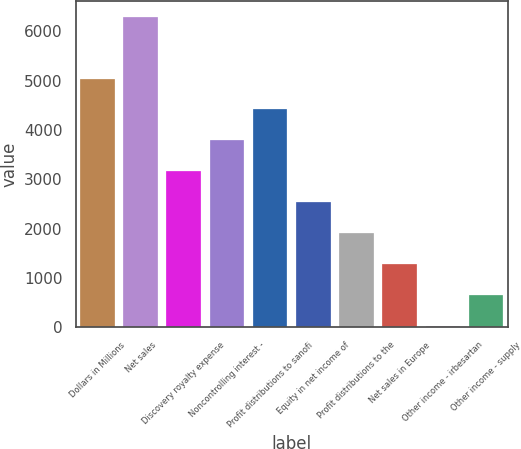<chart> <loc_0><loc_0><loc_500><loc_500><bar_chart><fcel>Dollars in Millions<fcel>Net sales<fcel>Discovery royalty expense<fcel>Noncontrolling interest -<fcel>Profit distributions to sanofi<fcel>Equity in net income of<fcel>Profit distributions to the<fcel>Net sales in Europe<fcel>Other income - irbesartan<fcel>Other income - supply<nl><fcel>5043<fcel>6296<fcel>3163.5<fcel>3790<fcel>4416.5<fcel>2537<fcel>1910.5<fcel>1284<fcel>31<fcel>657.5<nl></chart> 